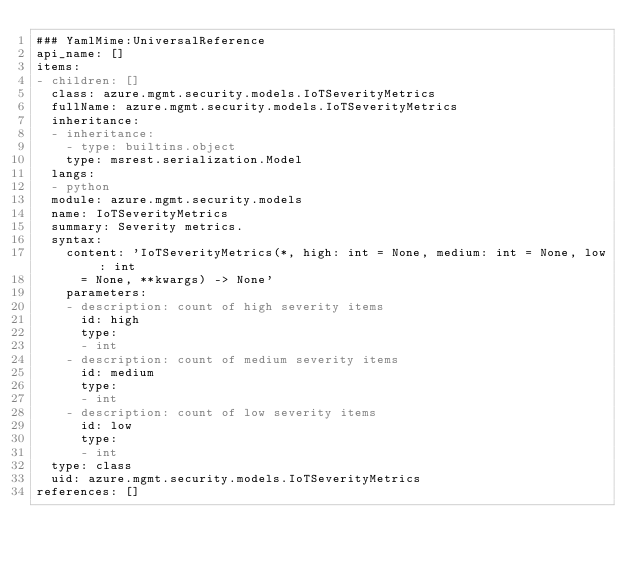Convert code to text. <code><loc_0><loc_0><loc_500><loc_500><_YAML_>### YamlMime:UniversalReference
api_name: []
items:
- children: []
  class: azure.mgmt.security.models.IoTSeverityMetrics
  fullName: azure.mgmt.security.models.IoTSeverityMetrics
  inheritance:
  - inheritance:
    - type: builtins.object
    type: msrest.serialization.Model
  langs:
  - python
  module: azure.mgmt.security.models
  name: IoTSeverityMetrics
  summary: Severity metrics.
  syntax:
    content: 'IoTSeverityMetrics(*, high: int = None, medium: int = None, low: int
      = None, **kwargs) -> None'
    parameters:
    - description: count of high severity items
      id: high
      type:
      - int
    - description: count of medium severity items
      id: medium
      type:
      - int
    - description: count of low severity items
      id: low
      type:
      - int
  type: class
  uid: azure.mgmt.security.models.IoTSeverityMetrics
references: []
</code> 